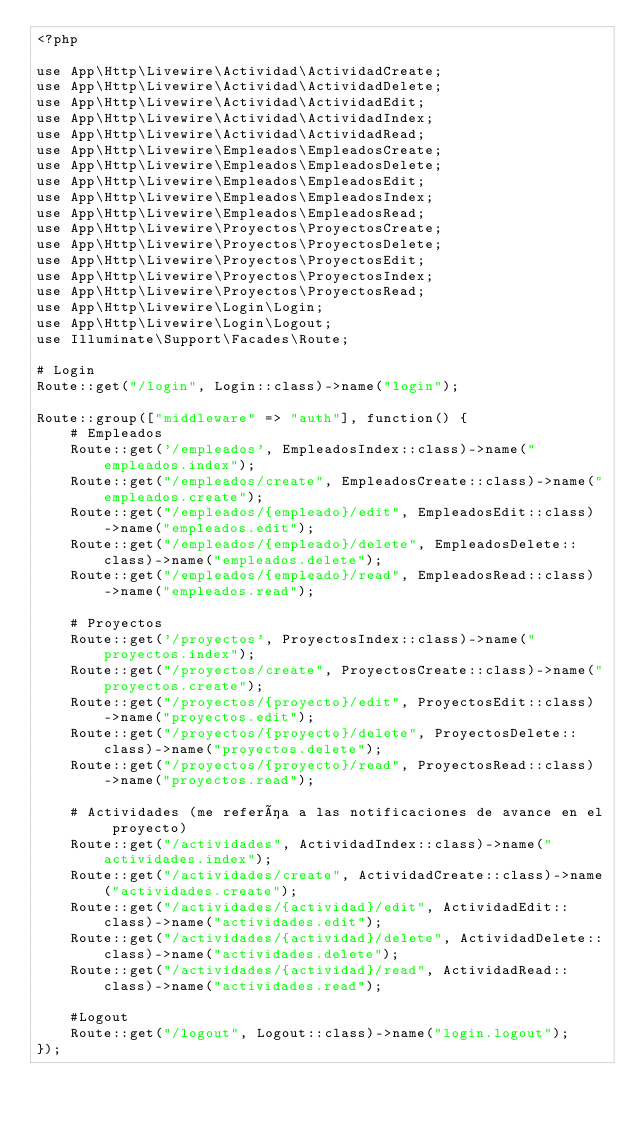Convert code to text. <code><loc_0><loc_0><loc_500><loc_500><_PHP_><?php

use App\Http\Livewire\Actividad\ActividadCreate;
use App\Http\Livewire\Actividad\ActividadDelete;
use App\Http\Livewire\Actividad\ActividadEdit;
use App\Http\Livewire\Actividad\ActividadIndex;
use App\Http\Livewire\Actividad\ActividadRead;
use App\Http\Livewire\Empleados\EmpleadosCreate;
use App\Http\Livewire\Empleados\EmpleadosDelete;
use App\Http\Livewire\Empleados\EmpleadosEdit;
use App\Http\Livewire\Empleados\EmpleadosIndex;
use App\Http\Livewire\Empleados\EmpleadosRead;
use App\Http\Livewire\Proyectos\ProyectosCreate;
use App\Http\Livewire\Proyectos\ProyectosDelete;
use App\Http\Livewire\Proyectos\ProyectosEdit;
use App\Http\Livewire\Proyectos\ProyectosIndex;
use App\Http\Livewire\Proyectos\ProyectosRead;
use App\Http\Livewire\Login\Login;
use App\Http\Livewire\Login\Logout;
use Illuminate\Support\Facades\Route;

# Login
Route::get("/login", Login::class)->name("login");

Route::group(["middleware" => "auth"], function() {
    # Empleados
    Route::get('/empleados', EmpleadosIndex::class)->name("empleados.index");
    Route::get("/empleados/create", EmpleadosCreate::class)->name("empleados.create");
    Route::get("/empleados/{empleado}/edit", EmpleadosEdit::class)->name("empleados.edit");
    Route::get("/empleados/{empleado}/delete", EmpleadosDelete::class)->name("empleados.delete");
    Route::get("/empleados/{empleado}/read", EmpleadosRead::class)->name("empleados.read");

    # Proyectos
    Route::get('/proyectos', ProyectosIndex::class)->name("proyectos.index");
    Route::get("/proyectos/create", ProyectosCreate::class)->name("proyectos.create");
    Route::get("/proyectos/{proyecto}/edit", ProyectosEdit::class)->name("proyectos.edit");
    Route::get("/proyectos/{proyecto}/delete", ProyectosDelete::class)->name("proyectos.delete");
    Route::get("/proyectos/{proyecto}/read", ProyectosRead::class)->name("proyectos.read");

    # Actividades (me refería a las notificaciones de avance en el proyecto)
    Route::get("/actividades", ActividadIndex::class)->name("actividades.index");
    Route::get("/actividades/create", ActividadCreate::class)->name("actividades.create");
    Route::get("/actividades/{actividad}/edit", ActividadEdit::class)->name("actividades.edit");
    Route::get("/actividades/{actividad}/delete", ActividadDelete::class)->name("actividades.delete");
    Route::get("/actividades/{actividad}/read", ActividadRead::class)->name("actividades.read");

    #Logout
    Route::get("/logout", Logout::class)->name("login.logout");
});

</code> 